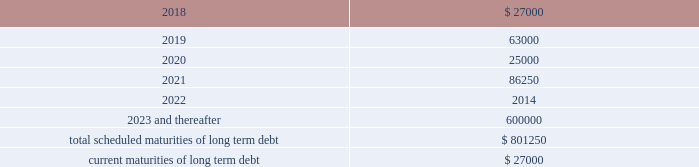Other long term debt in december 2012 , the company entered into a $ 50.0 million recourse loan collateralized by the land , buildings and tenant improvements comprising the company 2019s corporate headquarters .
The loan has a seven year term and maturity date of december 2019 .
The loan bears interest at one month libor plus a margin of 1.50% ( 1.50 % ) , and allows for prepayment without penalty .
The loan includes covenants and events of default substantially consistent with the company 2019s credit agreement discussed above .
The loan also requires prior approval of the lender for certain matters related to the property , including transfers of any interest in the property .
As of december 31 , 2017 and 2016 , the outstanding balance on the loan was $ 40.0 million and $ 42.0 million , respectively .
The weighted average interest rate on the loan was 2.5% ( 2.5 % ) and 2.0% ( 2.0 % ) for the years ended december 31 , 2017 and 2016 , respectively .
The following are the scheduled maturities of long term debt as of december 31 , 2017 : ( in thousands ) .
Interest expense , net was $ 34.5 million , $ 26.4 million , and $ 14.6 million for the years ended december 31 , 2017 , 2016 and 2015 , respectively .
Interest expense includes the amortization of deferred financing costs , bank fees , capital and built-to-suit lease interest and interest expense under the credit and other long term debt facilities .
Amortization of deferred financing costs was $ 1.3 million , $ 1.2 million , and $ 0.8 million for the years ended december 31 , 2017 , 2016 and 2015 , respectively .
The company monitors the financial health and stability of its lenders under the credit and other long term debt facilities , however during any period of significant instability in the credit markets lenders could be negatively impacted in their ability to perform under these facilities .
Commitments and contingencies obligations under operating leases the company leases warehouse space , office facilities , space for its brand and factory house stores and certain equipment under non-cancelable operating leases .
The leases expire at various dates through 2033 , excluding extensions at the company 2019s option , and include provisions for rental adjustments .
The table below includes executed lease agreements for brand and factory house stores that the company did not yet occupy as of december 31 , 2017 and does not include contingent rent the company may incur at its stores based on future sales above a specified minimum or payments made for maintenance , insurance and real estate taxes .
The following is a schedule of future minimum lease payments for non-cancelable real property operating leases as of december 31 , 2017 as well as .
What is the percentage change in the balance of outstanding loan from 2016 to 2017? 
Computations: ((42.0 - 40.0) / 40.0)
Answer: 0.05. 